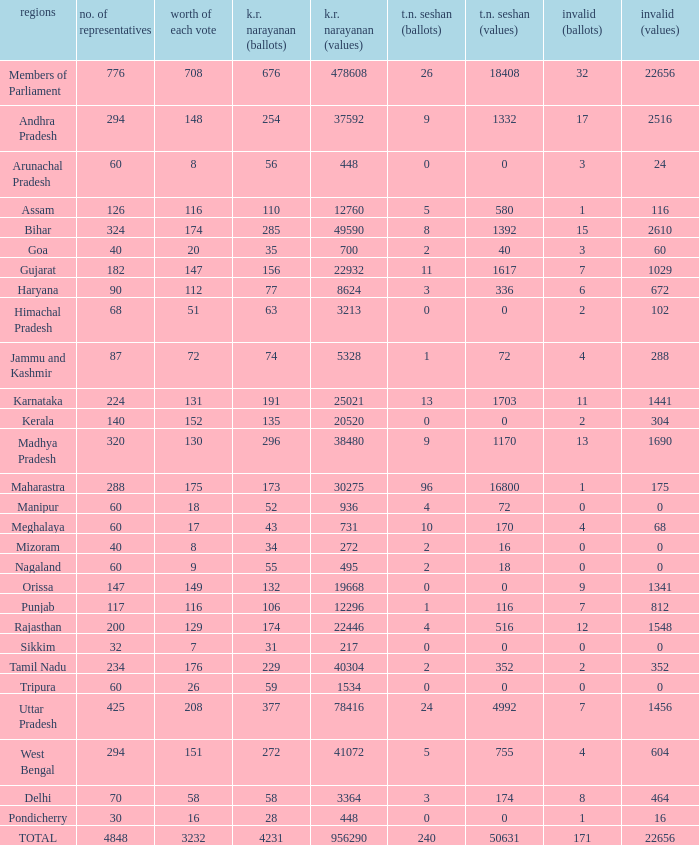Name the kr narayanan votes for values being 936 for kr 52.0. 